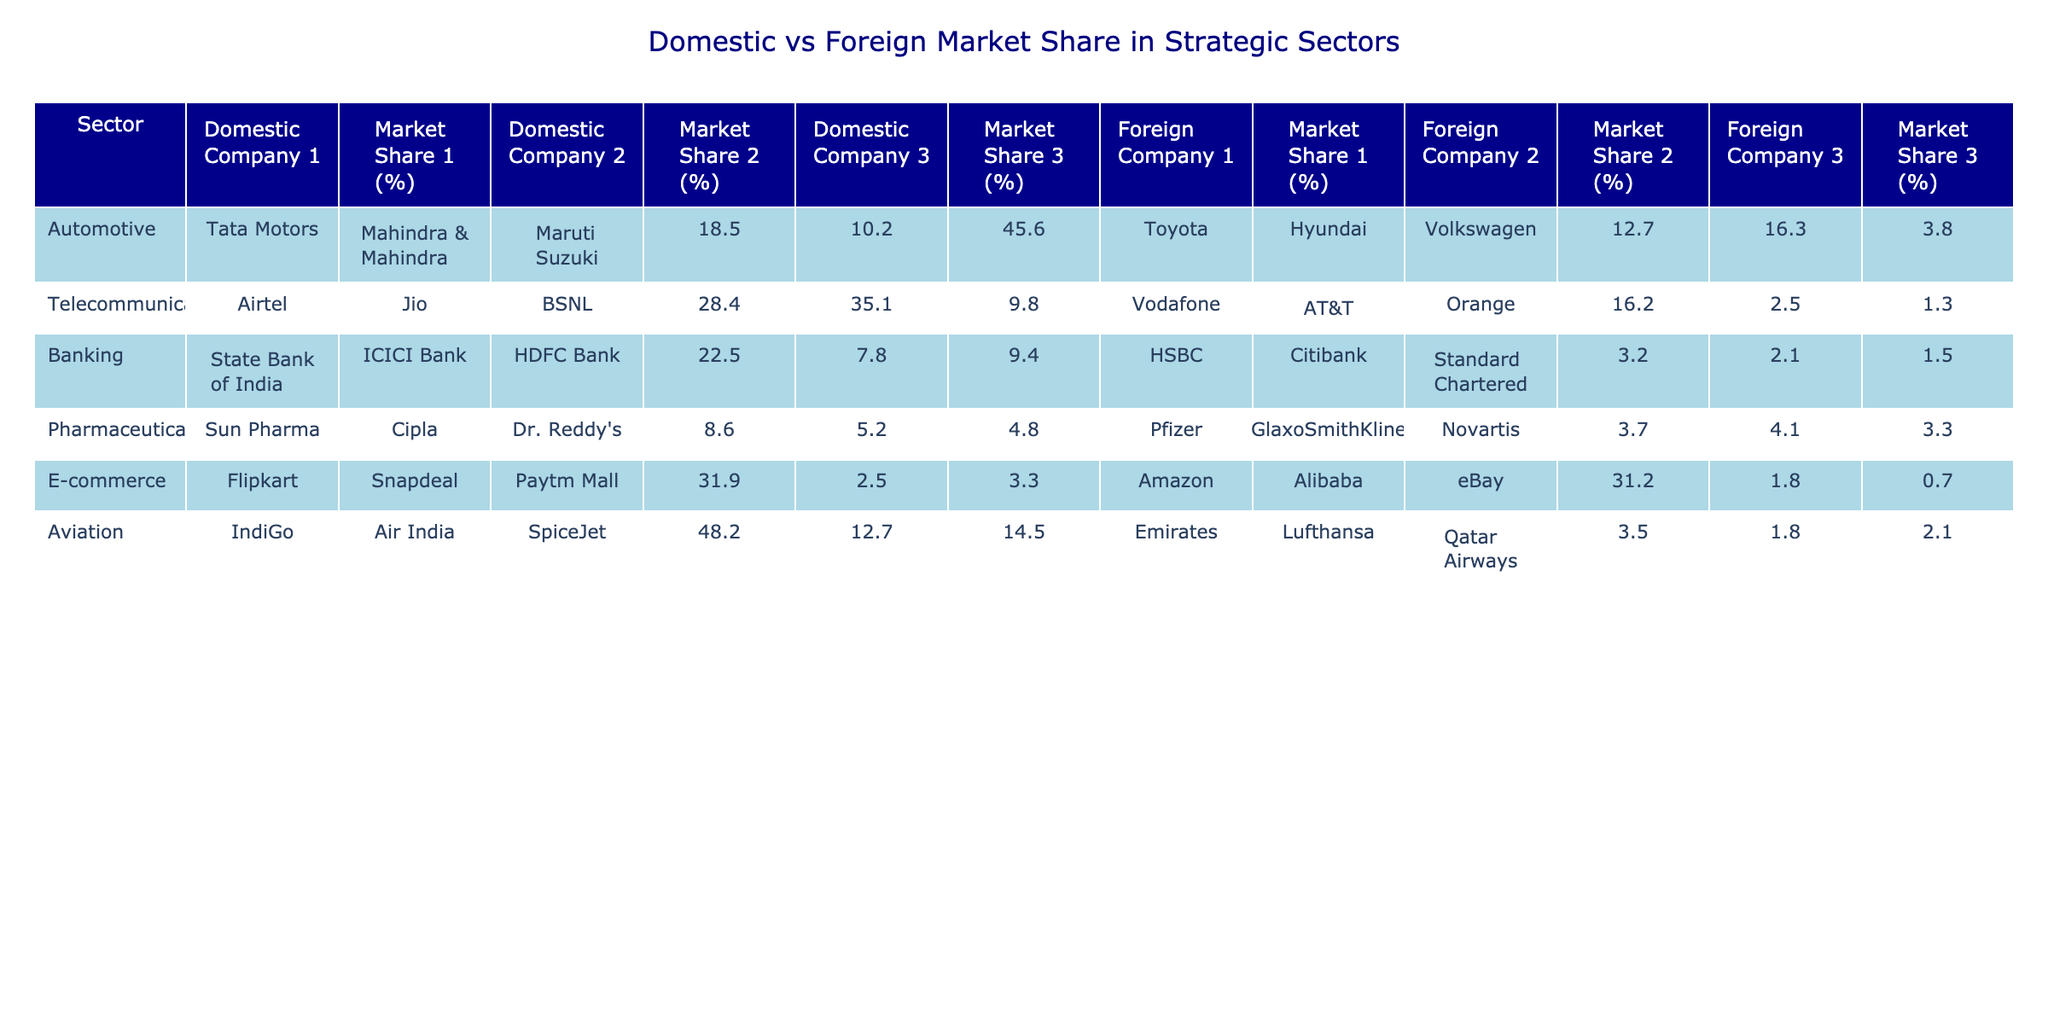What is the domestic market share of Maruti Suzuki in the automotive sector? According to the table, Maruti Suzuki has a domestic market share of 45.6% in the automotive sector.
Answer: 45.6% Which foreign company has the highest market share in the telecommunications sector? Examining the table, Jio is the foreign company with the highest market share at 35.1% in the telecommunications sector.
Answer: Jio How much higher is Maruti Suzuki's market share compared to Toyota's in the automotive sector? Maruti Suzuki has a market share of 45.6% and Toyota has 12.7%. The difference is 45.6% - 12.7% = 32.9%.
Answer: 32.9% Which sector has the lowest collective domestic market share among the top three companies? In the pharmaceuticals sector, the domestic market shares are 8.6% (Sun Pharma), 5.2% (Cipla), and 4.8% (Dr. Reddy's), resulting in a total of 8.6% + 5.2% + 4.8% = 18.6%, the lowest among all sectors.
Answer: Pharmaceuticals What is the combined market share of domestic companies in the banking sector? The domestic companies in banking have market shares of 22.5% (State Bank of India), 7.8% (ICICI Bank), and 9.4% (HDFC Bank). Summing them gives 22.5% + 7.8% + 9.4% = 39.7%.
Answer: 39.7% Is the combined market share of foreign companies in the e-commerce sector higher than 35%? Analyzing the e-commerce foreign company market shares: Amazon (31.2%), Alibaba (1.8%), and eBay (0.7%). Their total is 31.2% + 1.8% + 0.7% = 33.7%, which is less than 35%.
Answer: No In which sector does the domestic company have the highest market share, and what is that share? Looking through the table, IndiGo in the aviation sector has the highest domestic market share of 48.2%.
Answer: Aviation, 48.2% Which foreign company has the lowest market share, and in which sector? The table shows that Orange holds the lowest foreign market share at 1.3% in the telecommunications sector.
Answer: Orange, Telecommunications How does the market share of domestic companies in the automotive sector compare to that of the telecommunications sector? The total domestic market share in the automotive sector is 18.5% + 10.2% + 45.6% = 74.3%, while in telecommunications, it's 28.4% + 35.1% + 9.8% = 73.3%. Thus, the automotive sector has a higher share.
Answer: Automotive sector higher What is the difference between the market share of the top domestic company in the aviation sector and the top foreign company? IndiGo has a domestic market share of 48.2% and Emirates has 3.5%. The difference is 48.2% - 3.5% = 44.7%.
Answer: 44.7% 